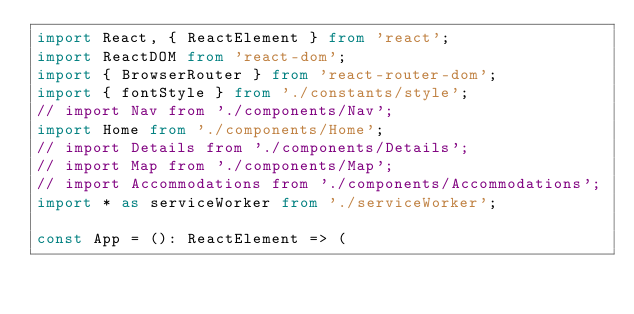<code> <loc_0><loc_0><loc_500><loc_500><_TypeScript_>import React, { ReactElement } from 'react';
import ReactDOM from 'react-dom';
import { BrowserRouter } from 'react-router-dom';
import { fontStyle } from './constants/style';
// import Nav from './components/Nav';
import Home from './components/Home';
// import Details from './components/Details';
// import Map from './components/Map';
// import Accommodations from './components/Accommodations';
import * as serviceWorker from './serviceWorker';

const App = (): ReactElement => (</code> 